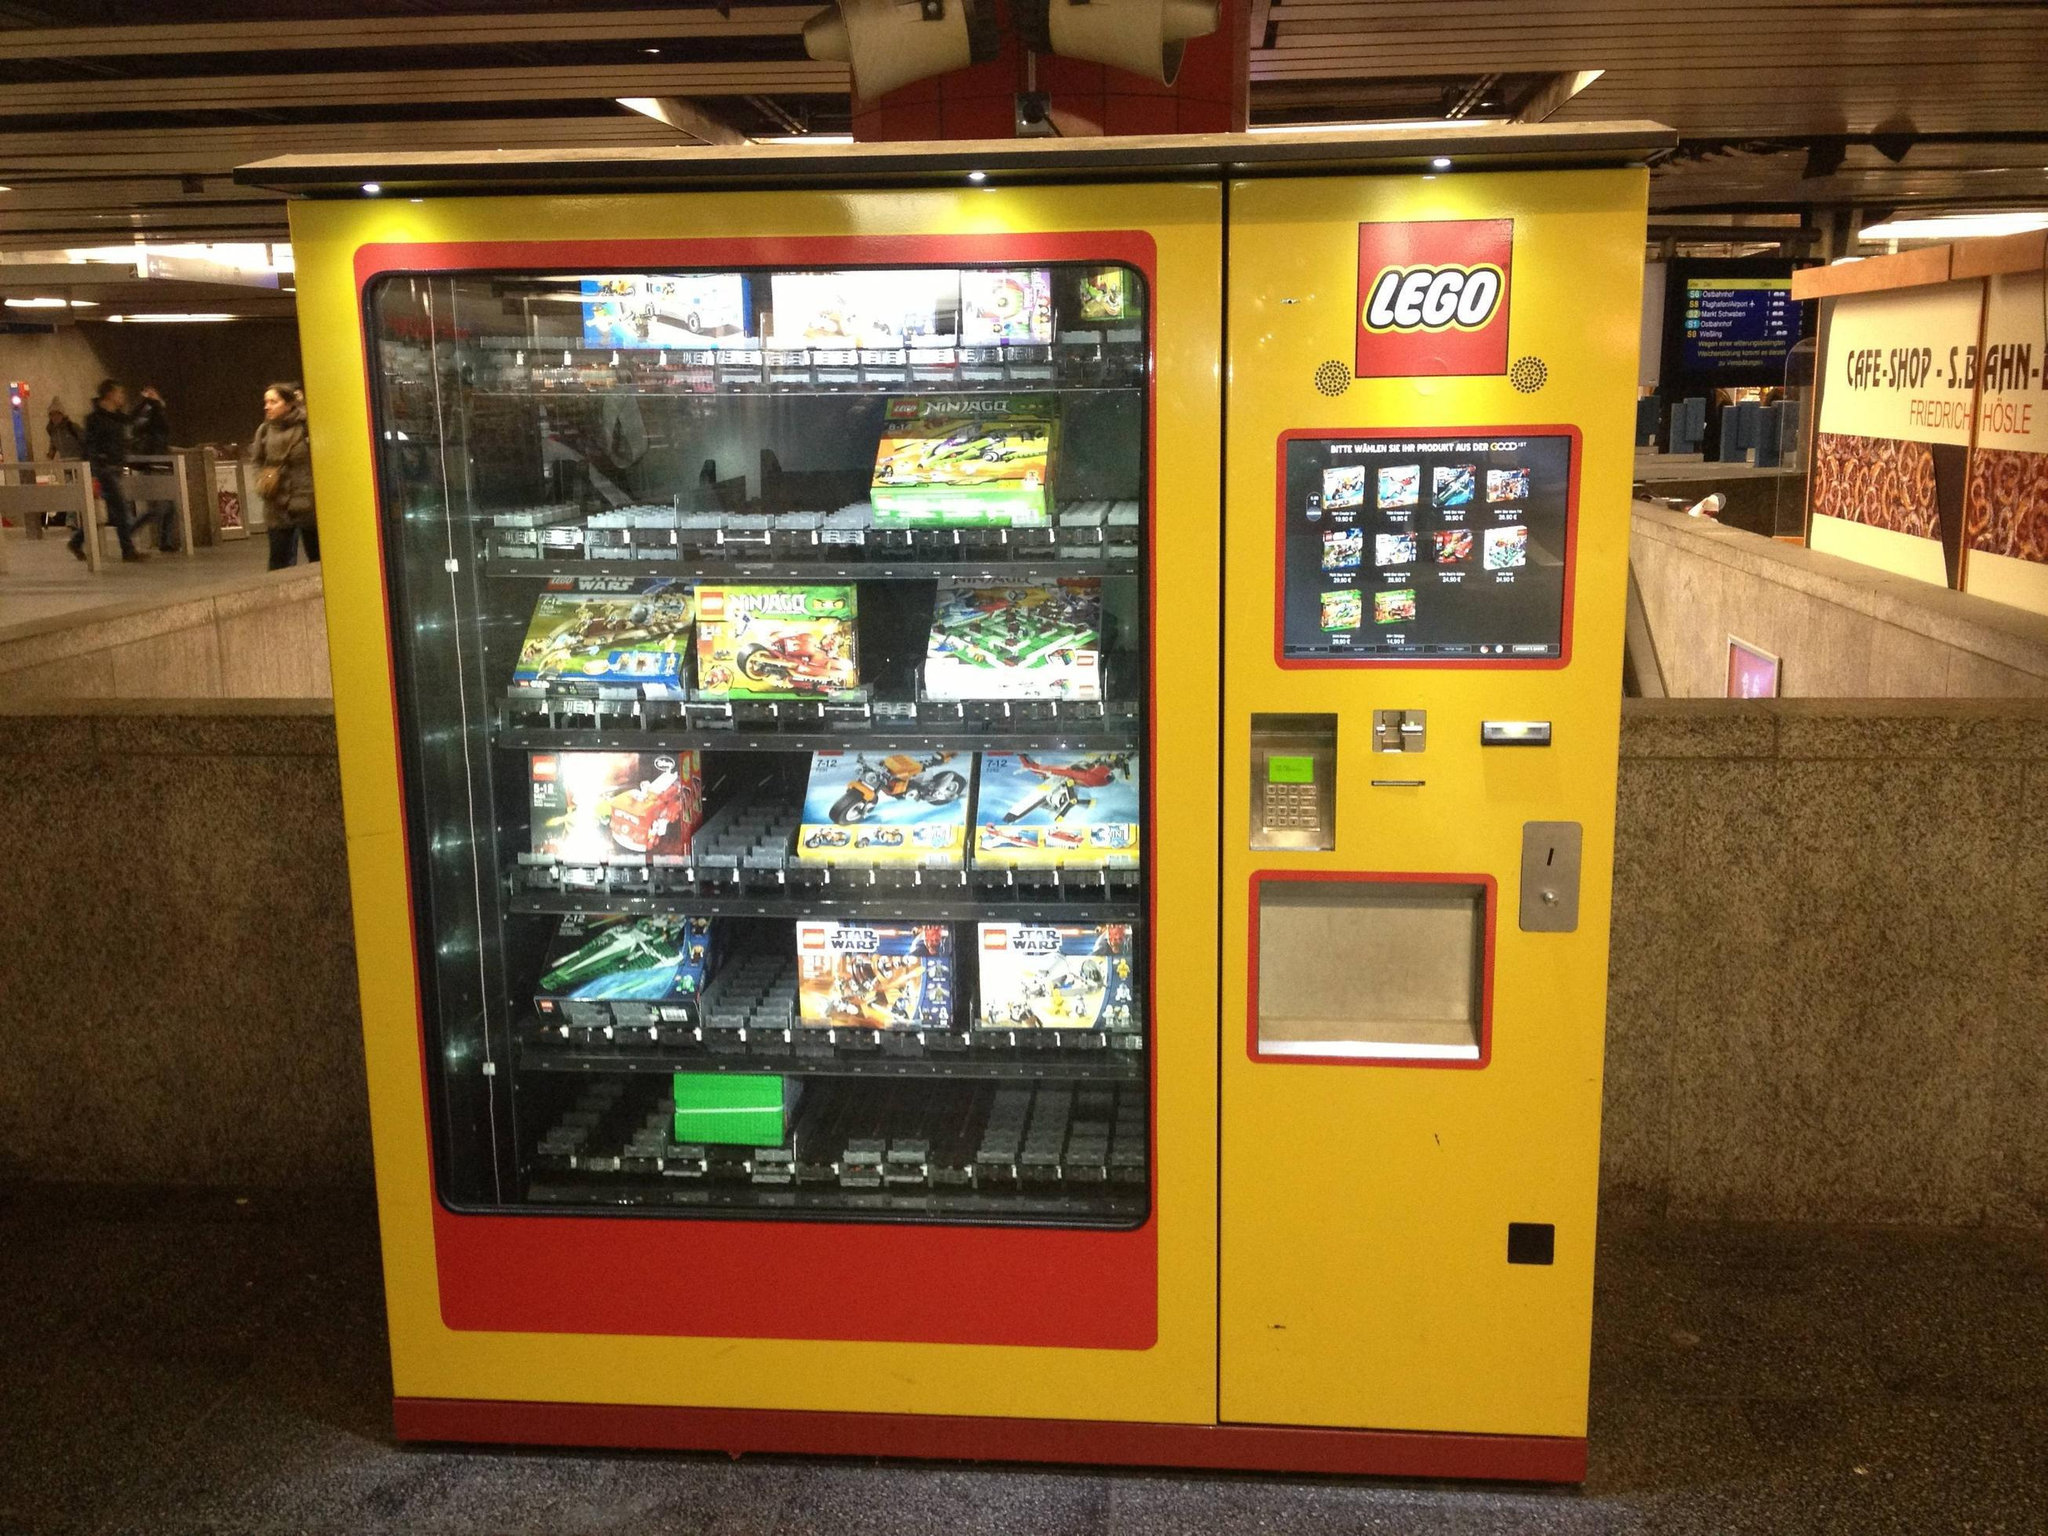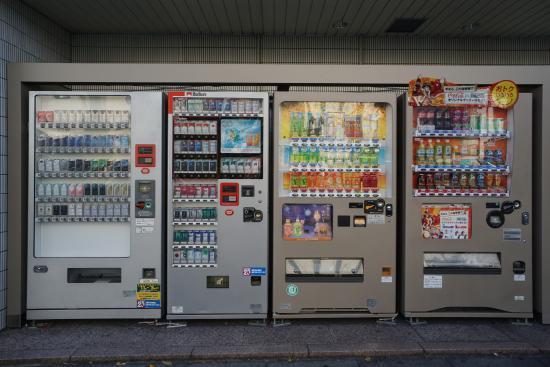The first image is the image on the left, the second image is the image on the right. Assess this claim about the two images: "At least one of the images contains only a single vending machine.". Correct or not? Answer yes or no. Yes. The first image is the image on the left, the second image is the image on the right. Considering the images on both sides, is "In the left image, there are at least four different vending machines." valid? Answer yes or no. No. 